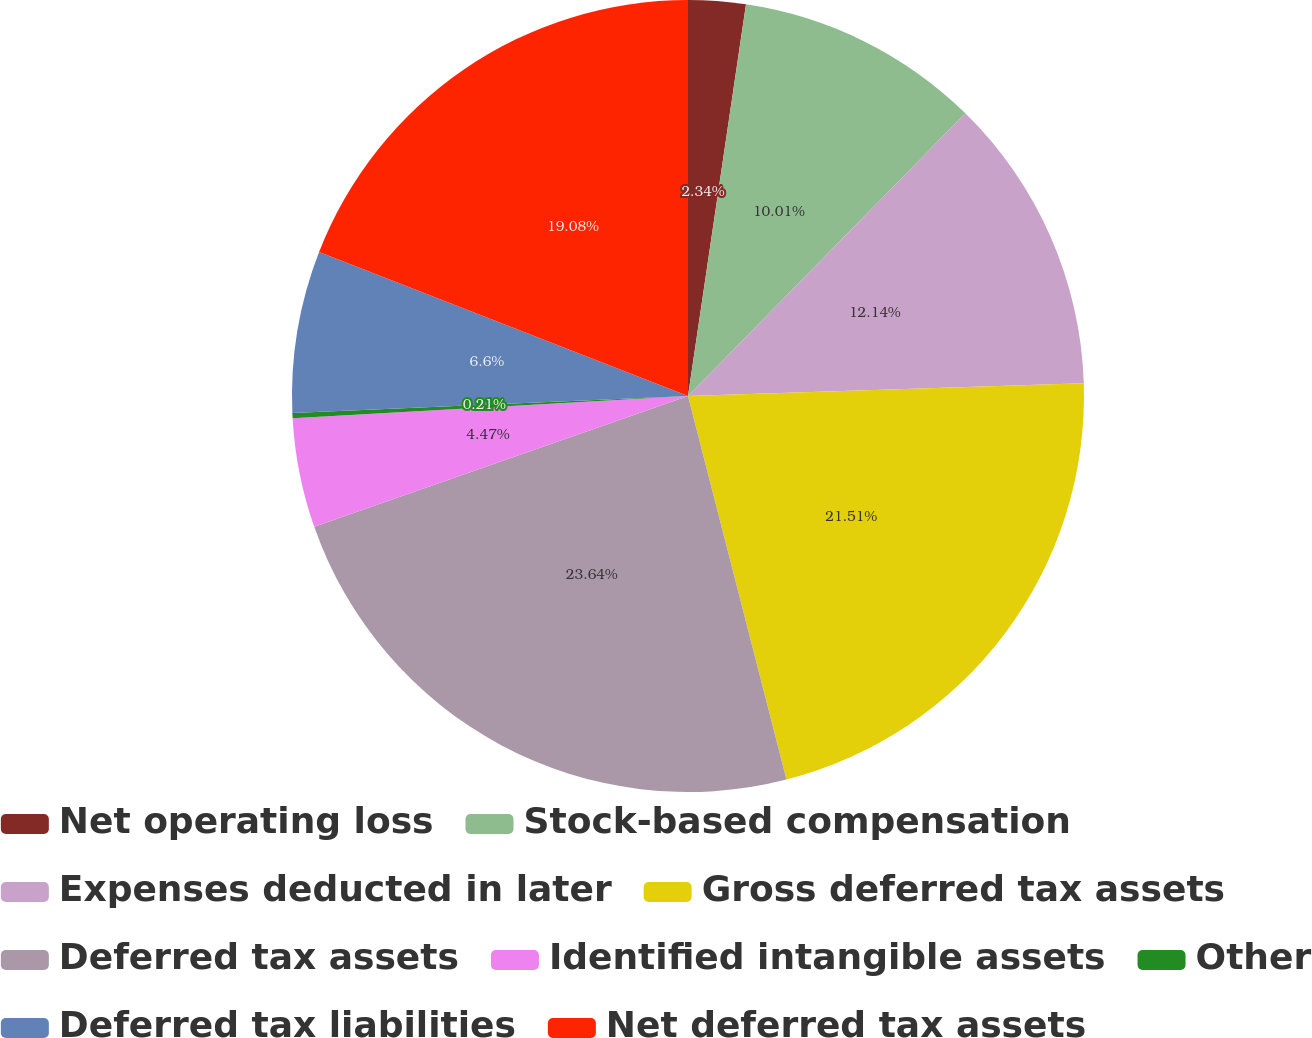<chart> <loc_0><loc_0><loc_500><loc_500><pie_chart><fcel>Net operating loss<fcel>Stock-based compensation<fcel>Expenses deducted in later<fcel>Gross deferred tax assets<fcel>Deferred tax assets<fcel>Identified intangible assets<fcel>Other<fcel>Deferred tax liabilities<fcel>Net deferred tax assets<nl><fcel>2.34%<fcel>10.01%<fcel>12.14%<fcel>21.51%<fcel>23.64%<fcel>4.47%<fcel>0.21%<fcel>6.6%<fcel>19.08%<nl></chart> 